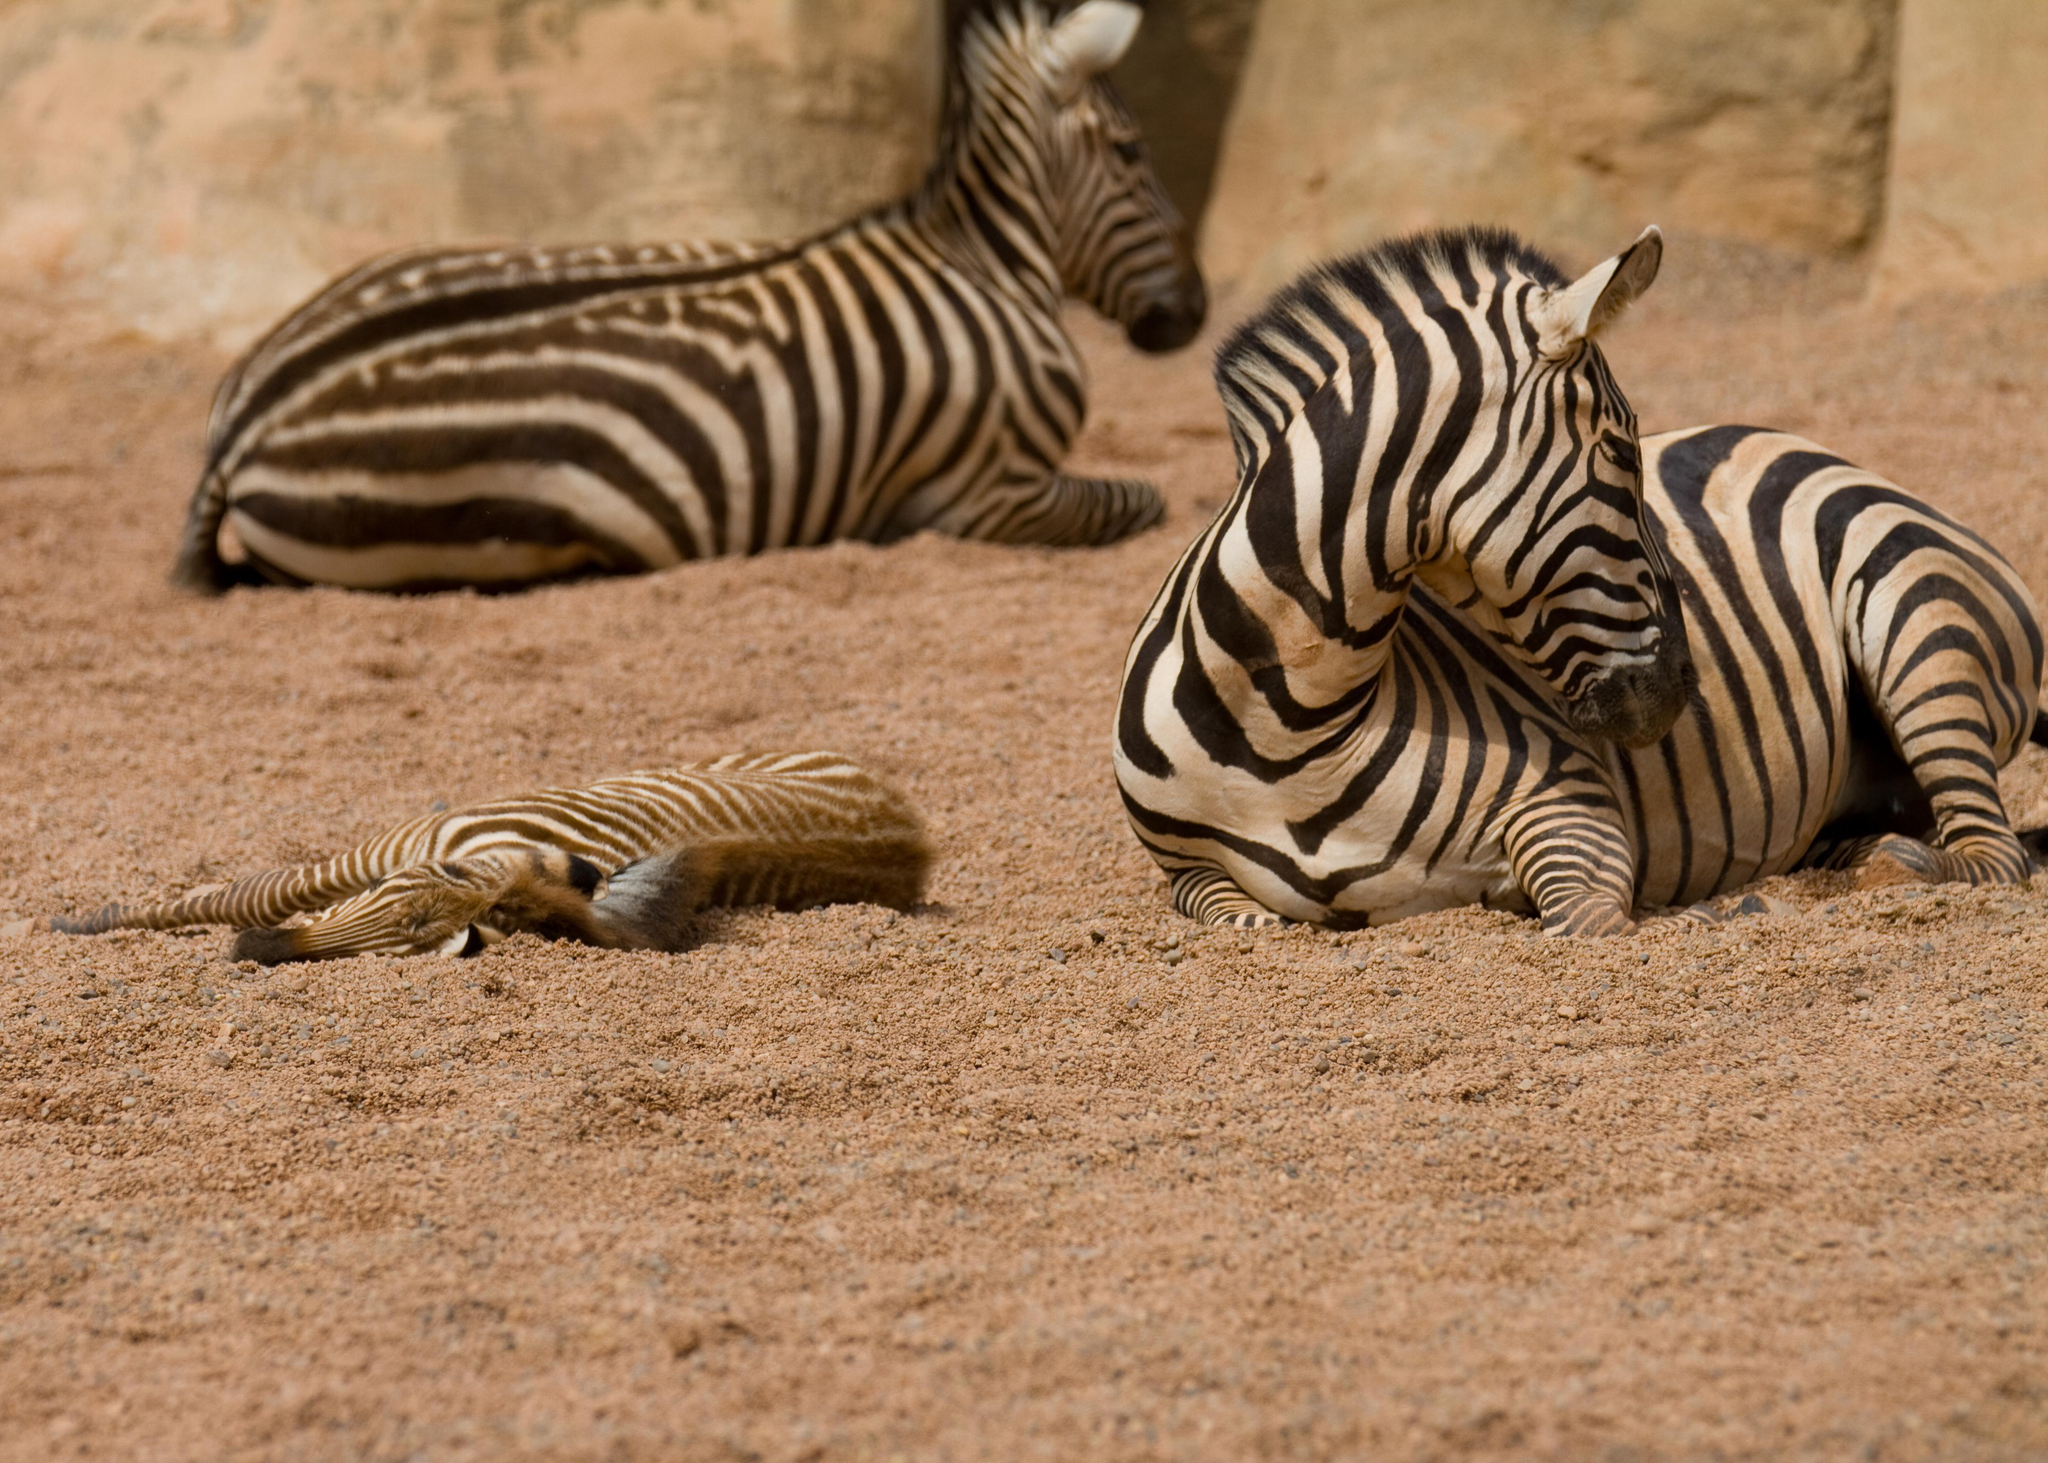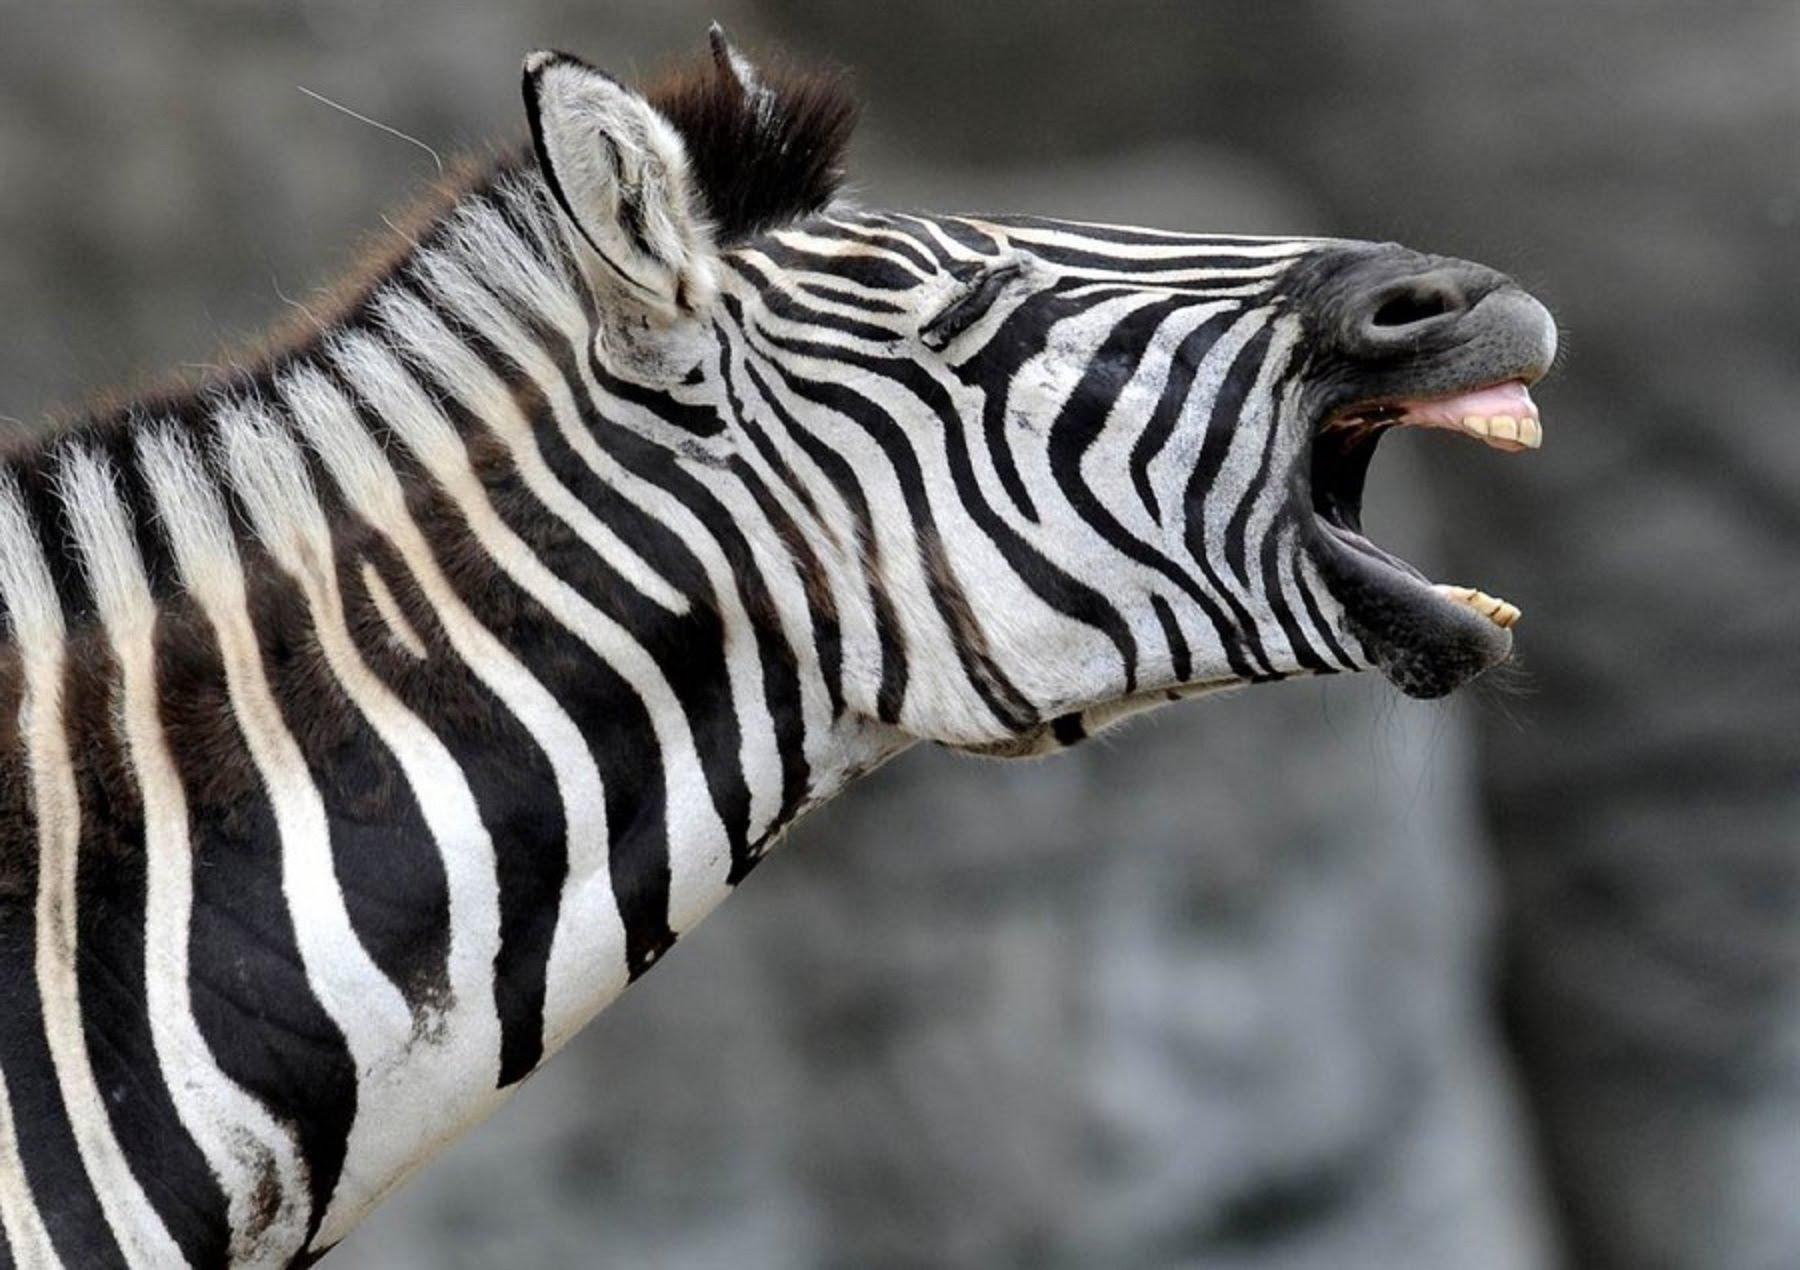The first image is the image on the left, the second image is the image on the right. Given the left and right images, does the statement "One image includes a zebra lying completely flat on the ground, and the othe image includes a zebra with its head lifted, mouth open and teeth showing in a braying pose." hold true? Answer yes or no. Yes. 